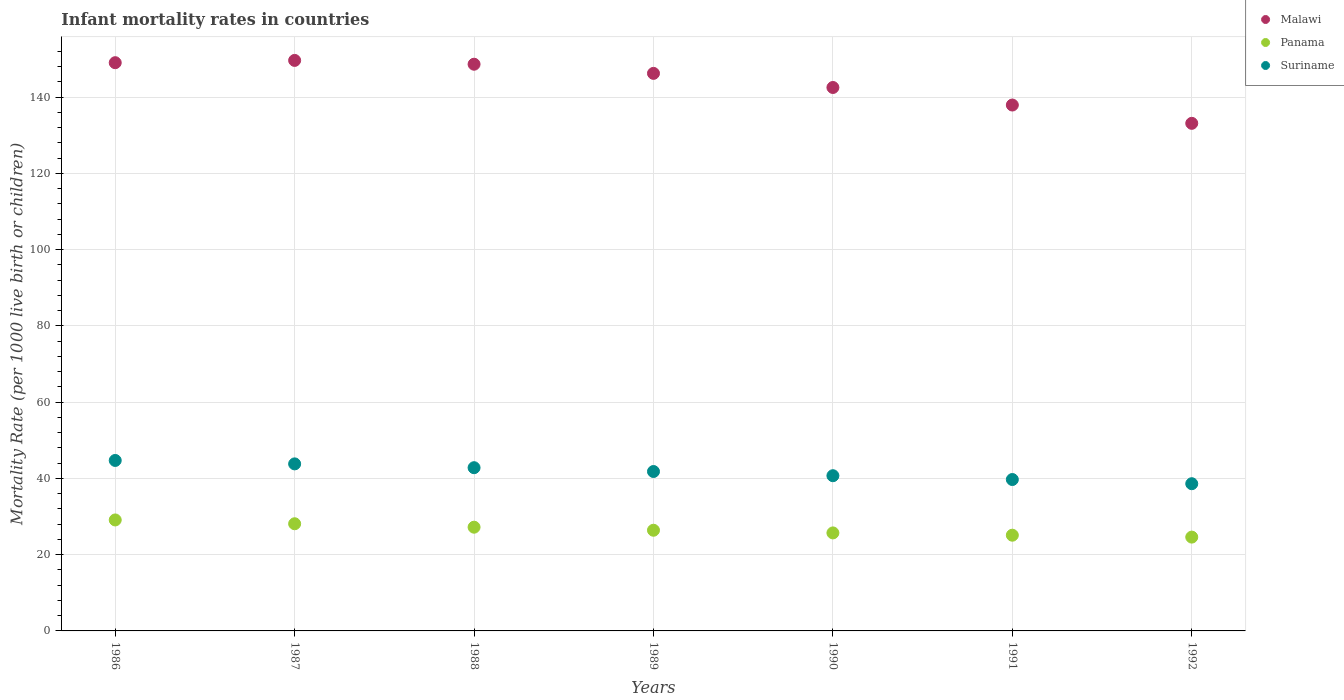Is the number of dotlines equal to the number of legend labels?
Provide a succinct answer. Yes. What is the infant mortality rate in Suriname in 1990?
Ensure brevity in your answer.  40.7. Across all years, what is the maximum infant mortality rate in Suriname?
Your answer should be compact. 44.7. Across all years, what is the minimum infant mortality rate in Suriname?
Give a very brief answer. 38.6. In which year was the infant mortality rate in Malawi minimum?
Offer a very short reply. 1992. What is the total infant mortality rate in Malawi in the graph?
Provide a succinct answer. 1006.9. What is the difference between the infant mortality rate in Suriname in 1989 and that in 1991?
Make the answer very short. 2.1. What is the difference between the infant mortality rate in Panama in 1988 and the infant mortality rate in Malawi in 1990?
Your answer should be very brief. -115.3. What is the average infant mortality rate in Suriname per year?
Your answer should be very brief. 41.73. In the year 1987, what is the difference between the infant mortality rate in Panama and infant mortality rate in Suriname?
Ensure brevity in your answer.  -15.7. What is the ratio of the infant mortality rate in Panama in 1988 to that in 1991?
Provide a short and direct response. 1.08. Is the infant mortality rate in Suriname in 1988 less than that in 1989?
Provide a succinct answer. No. Is the difference between the infant mortality rate in Panama in 1988 and 1989 greater than the difference between the infant mortality rate in Suriname in 1988 and 1989?
Your answer should be compact. No. What is the difference between the highest and the second highest infant mortality rate in Malawi?
Give a very brief answer. 0.6. What is the difference between the highest and the lowest infant mortality rate in Malawi?
Your answer should be very brief. 16.5. In how many years, is the infant mortality rate in Malawi greater than the average infant mortality rate in Malawi taken over all years?
Give a very brief answer. 4. Is the sum of the infant mortality rate in Suriname in 1986 and 1988 greater than the maximum infant mortality rate in Panama across all years?
Offer a very short reply. Yes. Is it the case that in every year, the sum of the infant mortality rate in Suriname and infant mortality rate in Malawi  is greater than the infant mortality rate in Panama?
Offer a very short reply. Yes. Is the infant mortality rate in Suriname strictly greater than the infant mortality rate in Panama over the years?
Make the answer very short. Yes. Is the infant mortality rate in Panama strictly less than the infant mortality rate in Malawi over the years?
Keep it short and to the point. Yes. Are the values on the major ticks of Y-axis written in scientific E-notation?
Keep it short and to the point. No. Does the graph contain any zero values?
Offer a very short reply. No. Does the graph contain grids?
Keep it short and to the point. Yes. Where does the legend appear in the graph?
Your answer should be very brief. Top right. How many legend labels are there?
Make the answer very short. 3. How are the legend labels stacked?
Keep it short and to the point. Vertical. What is the title of the graph?
Provide a succinct answer. Infant mortality rates in countries. What is the label or title of the Y-axis?
Your response must be concise. Mortality Rate (per 1000 live birth or children). What is the Mortality Rate (per 1000 live birth or children) in Malawi in 1986?
Keep it short and to the point. 149. What is the Mortality Rate (per 1000 live birth or children) of Panama in 1986?
Give a very brief answer. 29.1. What is the Mortality Rate (per 1000 live birth or children) in Suriname in 1986?
Offer a very short reply. 44.7. What is the Mortality Rate (per 1000 live birth or children) of Malawi in 1987?
Make the answer very short. 149.6. What is the Mortality Rate (per 1000 live birth or children) in Panama in 1987?
Give a very brief answer. 28.1. What is the Mortality Rate (per 1000 live birth or children) in Suriname in 1987?
Offer a very short reply. 43.8. What is the Mortality Rate (per 1000 live birth or children) in Malawi in 1988?
Provide a short and direct response. 148.6. What is the Mortality Rate (per 1000 live birth or children) of Panama in 1988?
Your answer should be compact. 27.2. What is the Mortality Rate (per 1000 live birth or children) in Suriname in 1988?
Your response must be concise. 42.8. What is the Mortality Rate (per 1000 live birth or children) in Malawi in 1989?
Your response must be concise. 146.2. What is the Mortality Rate (per 1000 live birth or children) in Panama in 1989?
Make the answer very short. 26.4. What is the Mortality Rate (per 1000 live birth or children) of Suriname in 1989?
Offer a terse response. 41.8. What is the Mortality Rate (per 1000 live birth or children) of Malawi in 1990?
Offer a terse response. 142.5. What is the Mortality Rate (per 1000 live birth or children) of Panama in 1990?
Ensure brevity in your answer.  25.7. What is the Mortality Rate (per 1000 live birth or children) in Suriname in 1990?
Your answer should be very brief. 40.7. What is the Mortality Rate (per 1000 live birth or children) of Malawi in 1991?
Provide a short and direct response. 137.9. What is the Mortality Rate (per 1000 live birth or children) of Panama in 1991?
Ensure brevity in your answer.  25.1. What is the Mortality Rate (per 1000 live birth or children) in Suriname in 1991?
Your answer should be very brief. 39.7. What is the Mortality Rate (per 1000 live birth or children) in Malawi in 1992?
Your answer should be compact. 133.1. What is the Mortality Rate (per 1000 live birth or children) in Panama in 1992?
Offer a terse response. 24.6. What is the Mortality Rate (per 1000 live birth or children) of Suriname in 1992?
Make the answer very short. 38.6. Across all years, what is the maximum Mortality Rate (per 1000 live birth or children) in Malawi?
Make the answer very short. 149.6. Across all years, what is the maximum Mortality Rate (per 1000 live birth or children) of Panama?
Your answer should be very brief. 29.1. Across all years, what is the maximum Mortality Rate (per 1000 live birth or children) of Suriname?
Offer a terse response. 44.7. Across all years, what is the minimum Mortality Rate (per 1000 live birth or children) of Malawi?
Ensure brevity in your answer.  133.1. Across all years, what is the minimum Mortality Rate (per 1000 live birth or children) of Panama?
Provide a succinct answer. 24.6. Across all years, what is the minimum Mortality Rate (per 1000 live birth or children) in Suriname?
Your answer should be compact. 38.6. What is the total Mortality Rate (per 1000 live birth or children) of Malawi in the graph?
Your answer should be very brief. 1006.9. What is the total Mortality Rate (per 1000 live birth or children) in Panama in the graph?
Offer a terse response. 186.2. What is the total Mortality Rate (per 1000 live birth or children) in Suriname in the graph?
Keep it short and to the point. 292.1. What is the difference between the Mortality Rate (per 1000 live birth or children) of Malawi in 1986 and that in 1987?
Ensure brevity in your answer.  -0.6. What is the difference between the Mortality Rate (per 1000 live birth or children) of Panama in 1986 and that in 1987?
Ensure brevity in your answer.  1. What is the difference between the Mortality Rate (per 1000 live birth or children) of Suriname in 1986 and that in 1987?
Give a very brief answer. 0.9. What is the difference between the Mortality Rate (per 1000 live birth or children) in Malawi in 1986 and that in 1988?
Offer a very short reply. 0.4. What is the difference between the Mortality Rate (per 1000 live birth or children) of Panama in 1986 and that in 1988?
Offer a very short reply. 1.9. What is the difference between the Mortality Rate (per 1000 live birth or children) of Panama in 1986 and that in 1989?
Your answer should be compact. 2.7. What is the difference between the Mortality Rate (per 1000 live birth or children) in Suriname in 1986 and that in 1989?
Provide a short and direct response. 2.9. What is the difference between the Mortality Rate (per 1000 live birth or children) of Panama in 1986 and that in 1990?
Provide a succinct answer. 3.4. What is the difference between the Mortality Rate (per 1000 live birth or children) of Suriname in 1986 and that in 1990?
Give a very brief answer. 4. What is the difference between the Mortality Rate (per 1000 live birth or children) of Panama in 1986 and that in 1991?
Your answer should be compact. 4. What is the difference between the Mortality Rate (per 1000 live birth or children) of Panama in 1986 and that in 1992?
Ensure brevity in your answer.  4.5. What is the difference between the Mortality Rate (per 1000 live birth or children) of Panama in 1987 and that in 1988?
Give a very brief answer. 0.9. What is the difference between the Mortality Rate (per 1000 live birth or children) in Malawi in 1987 and that in 1989?
Your response must be concise. 3.4. What is the difference between the Mortality Rate (per 1000 live birth or children) of Suriname in 1987 and that in 1989?
Make the answer very short. 2. What is the difference between the Mortality Rate (per 1000 live birth or children) of Panama in 1987 and that in 1990?
Provide a short and direct response. 2.4. What is the difference between the Mortality Rate (per 1000 live birth or children) in Panama in 1987 and that in 1991?
Provide a short and direct response. 3. What is the difference between the Mortality Rate (per 1000 live birth or children) of Malawi in 1988 and that in 1989?
Provide a short and direct response. 2.4. What is the difference between the Mortality Rate (per 1000 live birth or children) of Suriname in 1988 and that in 1989?
Provide a succinct answer. 1. What is the difference between the Mortality Rate (per 1000 live birth or children) of Malawi in 1988 and that in 1991?
Your answer should be very brief. 10.7. What is the difference between the Mortality Rate (per 1000 live birth or children) of Panama in 1988 and that in 1991?
Provide a succinct answer. 2.1. What is the difference between the Mortality Rate (per 1000 live birth or children) in Suriname in 1988 and that in 1991?
Keep it short and to the point. 3.1. What is the difference between the Mortality Rate (per 1000 live birth or children) in Panama in 1988 and that in 1992?
Make the answer very short. 2.6. What is the difference between the Mortality Rate (per 1000 live birth or children) of Malawi in 1989 and that in 1990?
Your response must be concise. 3.7. What is the difference between the Mortality Rate (per 1000 live birth or children) in Suriname in 1989 and that in 1990?
Offer a terse response. 1.1. What is the difference between the Mortality Rate (per 1000 live birth or children) of Panama in 1989 and that in 1991?
Provide a succinct answer. 1.3. What is the difference between the Mortality Rate (per 1000 live birth or children) in Suriname in 1989 and that in 1991?
Provide a short and direct response. 2.1. What is the difference between the Mortality Rate (per 1000 live birth or children) of Malawi in 1989 and that in 1992?
Your response must be concise. 13.1. What is the difference between the Mortality Rate (per 1000 live birth or children) in Panama in 1989 and that in 1992?
Your response must be concise. 1.8. What is the difference between the Mortality Rate (per 1000 live birth or children) in Suriname in 1989 and that in 1992?
Give a very brief answer. 3.2. What is the difference between the Mortality Rate (per 1000 live birth or children) in Panama in 1990 and that in 1991?
Your answer should be compact. 0.6. What is the difference between the Mortality Rate (per 1000 live birth or children) in Suriname in 1990 and that in 1991?
Your answer should be compact. 1. What is the difference between the Mortality Rate (per 1000 live birth or children) of Panama in 1990 and that in 1992?
Your answer should be compact. 1.1. What is the difference between the Mortality Rate (per 1000 live birth or children) in Suriname in 1990 and that in 1992?
Offer a very short reply. 2.1. What is the difference between the Mortality Rate (per 1000 live birth or children) in Malawi in 1991 and that in 1992?
Provide a succinct answer. 4.8. What is the difference between the Mortality Rate (per 1000 live birth or children) of Panama in 1991 and that in 1992?
Your answer should be very brief. 0.5. What is the difference between the Mortality Rate (per 1000 live birth or children) of Suriname in 1991 and that in 1992?
Provide a short and direct response. 1.1. What is the difference between the Mortality Rate (per 1000 live birth or children) of Malawi in 1986 and the Mortality Rate (per 1000 live birth or children) of Panama in 1987?
Give a very brief answer. 120.9. What is the difference between the Mortality Rate (per 1000 live birth or children) in Malawi in 1986 and the Mortality Rate (per 1000 live birth or children) in Suriname in 1987?
Offer a very short reply. 105.2. What is the difference between the Mortality Rate (per 1000 live birth or children) in Panama in 1986 and the Mortality Rate (per 1000 live birth or children) in Suriname in 1987?
Provide a short and direct response. -14.7. What is the difference between the Mortality Rate (per 1000 live birth or children) of Malawi in 1986 and the Mortality Rate (per 1000 live birth or children) of Panama in 1988?
Keep it short and to the point. 121.8. What is the difference between the Mortality Rate (per 1000 live birth or children) in Malawi in 1986 and the Mortality Rate (per 1000 live birth or children) in Suriname in 1988?
Provide a short and direct response. 106.2. What is the difference between the Mortality Rate (per 1000 live birth or children) of Panama in 1986 and the Mortality Rate (per 1000 live birth or children) of Suriname in 1988?
Provide a succinct answer. -13.7. What is the difference between the Mortality Rate (per 1000 live birth or children) of Malawi in 1986 and the Mortality Rate (per 1000 live birth or children) of Panama in 1989?
Your response must be concise. 122.6. What is the difference between the Mortality Rate (per 1000 live birth or children) of Malawi in 1986 and the Mortality Rate (per 1000 live birth or children) of Suriname in 1989?
Your response must be concise. 107.2. What is the difference between the Mortality Rate (per 1000 live birth or children) in Panama in 1986 and the Mortality Rate (per 1000 live birth or children) in Suriname in 1989?
Ensure brevity in your answer.  -12.7. What is the difference between the Mortality Rate (per 1000 live birth or children) in Malawi in 1986 and the Mortality Rate (per 1000 live birth or children) in Panama in 1990?
Provide a short and direct response. 123.3. What is the difference between the Mortality Rate (per 1000 live birth or children) in Malawi in 1986 and the Mortality Rate (per 1000 live birth or children) in Suriname in 1990?
Provide a short and direct response. 108.3. What is the difference between the Mortality Rate (per 1000 live birth or children) of Malawi in 1986 and the Mortality Rate (per 1000 live birth or children) of Panama in 1991?
Your response must be concise. 123.9. What is the difference between the Mortality Rate (per 1000 live birth or children) in Malawi in 1986 and the Mortality Rate (per 1000 live birth or children) in Suriname in 1991?
Your answer should be compact. 109.3. What is the difference between the Mortality Rate (per 1000 live birth or children) in Malawi in 1986 and the Mortality Rate (per 1000 live birth or children) in Panama in 1992?
Offer a very short reply. 124.4. What is the difference between the Mortality Rate (per 1000 live birth or children) in Malawi in 1986 and the Mortality Rate (per 1000 live birth or children) in Suriname in 1992?
Keep it short and to the point. 110.4. What is the difference between the Mortality Rate (per 1000 live birth or children) of Panama in 1986 and the Mortality Rate (per 1000 live birth or children) of Suriname in 1992?
Provide a succinct answer. -9.5. What is the difference between the Mortality Rate (per 1000 live birth or children) of Malawi in 1987 and the Mortality Rate (per 1000 live birth or children) of Panama in 1988?
Provide a succinct answer. 122.4. What is the difference between the Mortality Rate (per 1000 live birth or children) in Malawi in 1987 and the Mortality Rate (per 1000 live birth or children) in Suriname in 1988?
Your answer should be very brief. 106.8. What is the difference between the Mortality Rate (per 1000 live birth or children) in Panama in 1987 and the Mortality Rate (per 1000 live birth or children) in Suriname in 1988?
Provide a succinct answer. -14.7. What is the difference between the Mortality Rate (per 1000 live birth or children) of Malawi in 1987 and the Mortality Rate (per 1000 live birth or children) of Panama in 1989?
Offer a very short reply. 123.2. What is the difference between the Mortality Rate (per 1000 live birth or children) in Malawi in 1987 and the Mortality Rate (per 1000 live birth or children) in Suriname in 1989?
Provide a short and direct response. 107.8. What is the difference between the Mortality Rate (per 1000 live birth or children) of Panama in 1987 and the Mortality Rate (per 1000 live birth or children) of Suriname in 1989?
Keep it short and to the point. -13.7. What is the difference between the Mortality Rate (per 1000 live birth or children) in Malawi in 1987 and the Mortality Rate (per 1000 live birth or children) in Panama in 1990?
Ensure brevity in your answer.  123.9. What is the difference between the Mortality Rate (per 1000 live birth or children) of Malawi in 1987 and the Mortality Rate (per 1000 live birth or children) of Suriname in 1990?
Your answer should be compact. 108.9. What is the difference between the Mortality Rate (per 1000 live birth or children) in Panama in 1987 and the Mortality Rate (per 1000 live birth or children) in Suriname in 1990?
Ensure brevity in your answer.  -12.6. What is the difference between the Mortality Rate (per 1000 live birth or children) in Malawi in 1987 and the Mortality Rate (per 1000 live birth or children) in Panama in 1991?
Make the answer very short. 124.5. What is the difference between the Mortality Rate (per 1000 live birth or children) of Malawi in 1987 and the Mortality Rate (per 1000 live birth or children) of Suriname in 1991?
Provide a short and direct response. 109.9. What is the difference between the Mortality Rate (per 1000 live birth or children) of Malawi in 1987 and the Mortality Rate (per 1000 live birth or children) of Panama in 1992?
Provide a short and direct response. 125. What is the difference between the Mortality Rate (per 1000 live birth or children) of Malawi in 1987 and the Mortality Rate (per 1000 live birth or children) of Suriname in 1992?
Give a very brief answer. 111. What is the difference between the Mortality Rate (per 1000 live birth or children) in Panama in 1987 and the Mortality Rate (per 1000 live birth or children) in Suriname in 1992?
Give a very brief answer. -10.5. What is the difference between the Mortality Rate (per 1000 live birth or children) in Malawi in 1988 and the Mortality Rate (per 1000 live birth or children) in Panama in 1989?
Provide a short and direct response. 122.2. What is the difference between the Mortality Rate (per 1000 live birth or children) in Malawi in 1988 and the Mortality Rate (per 1000 live birth or children) in Suriname in 1989?
Make the answer very short. 106.8. What is the difference between the Mortality Rate (per 1000 live birth or children) of Panama in 1988 and the Mortality Rate (per 1000 live birth or children) of Suriname in 1989?
Your answer should be very brief. -14.6. What is the difference between the Mortality Rate (per 1000 live birth or children) in Malawi in 1988 and the Mortality Rate (per 1000 live birth or children) in Panama in 1990?
Give a very brief answer. 122.9. What is the difference between the Mortality Rate (per 1000 live birth or children) in Malawi in 1988 and the Mortality Rate (per 1000 live birth or children) in Suriname in 1990?
Provide a succinct answer. 107.9. What is the difference between the Mortality Rate (per 1000 live birth or children) in Malawi in 1988 and the Mortality Rate (per 1000 live birth or children) in Panama in 1991?
Make the answer very short. 123.5. What is the difference between the Mortality Rate (per 1000 live birth or children) of Malawi in 1988 and the Mortality Rate (per 1000 live birth or children) of Suriname in 1991?
Your response must be concise. 108.9. What is the difference between the Mortality Rate (per 1000 live birth or children) in Malawi in 1988 and the Mortality Rate (per 1000 live birth or children) in Panama in 1992?
Your response must be concise. 124. What is the difference between the Mortality Rate (per 1000 live birth or children) of Malawi in 1988 and the Mortality Rate (per 1000 live birth or children) of Suriname in 1992?
Give a very brief answer. 110. What is the difference between the Mortality Rate (per 1000 live birth or children) in Malawi in 1989 and the Mortality Rate (per 1000 live birth or children) in Panama in 1990?
Make the answer very short. 120.5. What is the difference between the Mortality Rate (per 1000 live birth or children) in Malawi in 1989 and the Mortality Rate (per 1000 live birth or children) in Suriname in 1990?
Ensure brevity in your answer.  105.5. What is the difference between the Mortality Rate (per 1000 live birth or children) of Panama in 1989 and the Mortality Rate (per 1000 live birth or children) of Suriname in 1990?
Ensure brevity in your answer.  -14.3. What is the difference between the Mortality Rate (per 1000 live birth or children) in Malawi in 1989 and the Mortality Rate (per 1000 live birth or children) in Panama in 1991?
Make the answer very short. 121.1. What is the difference between the Mortality Rate (per 1000 live birth or children) of Malawi in 1989 and the Mortality Rate (per 1000 live birth or children) of Suriname in 1991?
Provide a short and direct response. 106.5. What is the difference between the Mortality Rate (per 1000 live birth or children) in Panama in 1989 and the Mortality Rate (per 1000 live birth or children) in Suriname in 1991?
Give a very brief answer. -13.3. What is the difference between the Mortality Rate (per 1000 live birth or children) in Malawi in 1989 and the Mortality Rate (per 1000 live birth or children) in Panama in 1992?
Your answer should be very brief. 121.6. What is the difference between the Mortality Rate (per 1000 live birth or children) of Malawi in 1989 and the Mortality Rate (per 1000 live birth or children) of Suriname in 1992?
Make the answer very short. 107.6. What is the difference between the Mortality Rate (per 1000 live birth or children) in Panama in 1989 and the Mortality Rate (per 1000 live birth or children) in Suriname in 1992?
Give a very brief answer. -12.2. What is the difference between the Mortality Rate (per 1000 live birth or children) in Malawi in 1990 and the Mortality Rate (per 1000 live birth or children) in Panama in 1991?
Provide a succinct answer. 117.4. What is the difference between the Mortality Rate (per 1000 live birth or children) of Malawi in 1990 and the Mortality Rate (per 1000 live birth or children) of Suriname in 1991?
Ensure brevity in your answer.  102.8. What is the difference between the Mortality Rate (per 1000 live birth or children) of Panama in 1990 and the Mortality Rate (per 1000 live birth or children) of Suriname in 1991?
Offer a very short reply. -14. What is the difference between the Mortality Rate (per 1000 live birth or children) in Malawi in 1990 and the Mortality Rate (per 1000 live birth or children) in Panama in 1992?
Offer a very short reply. 117.9. What is the difference between the Mortality Rate (per 1000 live birth or children) of Malawi in 1990 and the Mortality Rate (per 1000 live birth or children) of Suriname in 1992?
Give a very brief answer. 103.9. What is the difference between the Mortality Rate (per 1000 live birth or children) of Panama in 1990 and the Mortality Rate (per 1000 live birth or children) of Suriname in 1992?
Your answer should be compact. -12.9. What is the difference between the Mortality Rate (per 1000 live birth or children) in Malawi in 1991 and the Mortality Rate (per 1000 live birth or children) in Panama in 1992?
Keep it short and to the point. 113.3. What is the difference between the Mortality Rate (per 1000 live birth or children) of Malawi in 1991 and the Mortality Rate (per 1000 live birth or children) of Suriname in 1992?
Offer a terse response. 99.3. What is the average Mortality Rate (per 1000 live birth or children) in Malawi per year?
Your answer should be very brief. 143.84. What is the average Mortality Rate (per 1000 live birth or children) of Panama per year?
Keep it short and to the point. 26.6. What is the average Mortality Rate (per 1000 live birth or children) in Suriname per year?
Your response must be concise. 41.73. In the year 1986, what is the difference between the Mortality Rate (per 1000 live birth or children) of Malawi and Mortality Rate (per 1000 live birth or children) of Panama?
Offer a very short reply. 119.9. In the year 1986, what is the difference between the Mortality Rate (per 1000 live birth or children) of Malawi and Mortality Rate (per 1000 live birth or children) of Suriname?
Your response must be concise. 104.3. In the year 1986, what is the difference between the Mortality Rate (per 1000 live birth or children) in Panama and Mortality Rate (per 1000 live birth or children) in Suriname?
Keep it short and to the point. -15.6. In the year 1987, what is the difference between the Mortality Rate (per 1000 live birth or children) of Malawi and Mortality Rate (per 1000 live birth or children) of Panama?
Ensure brevity in your answer.  121.5. In the year 1987, what is the difference between the Mortality Rate (per 1000 live birth or children) in Malawi and Mortality Rate (per 1000 live birth or children) in Suriname?
Give a very brief answer. 105.8. In the year 1987, what is the difference between the Mortality Rate (per 1000 live birth or children) of Panama and Mortality Rate (per 1000 live birth or children) of Suriname?
Ensure brevity in your answer.  -15.7. In the year 1988, what is the difference between the Mortality Rate (per 1000 live birth or children) of Malawi and Mortality Rate (per 1000 live birth or children) of Panama?
Provide a short and direct response. 121.4. In the year 1988, what is the difference between the Mortality Rate (per 1000 live birth or children) in Malawi and Mortality Rate (per 1000 live birth or children) in Suriname?
Keep it short and to the point. 105.8. In the year 1988, what is the difference between the Mortality Rate (per 1000 live birth or children) of Panama and Mortality Rate (per 1000 live birth or children) of Suriname?
Provide a succinct answer. -15.6. In the year 1989, what is the difference between the Mortality Rate (per 1000 live birth or children) of Malawi and Mortality Rate (per 1000 live birth or children) of Panama?
Provide a short and direct response. 119.8. In the year 1989, what is the difference between the Mortality Rate (per 1000 live birth or children) of Malawi and Mortality Rate (per 1000 live birth or children) of Suriname?
Provide a succinct answer. 104.4. In the year 1989, what is the difference between the Mortality Rate (per 1000 live birth or children) of Panama and Mortality Rate (per 1000 live birth or children) of Suriname?
Ensure brevity in your answer.  -15.4. In the year 1990, what is the difference between the Mortality Rate (per 1000 live birth or children) in Malawi and Mortality Rate (per 1000 live birth or children) in Panama?
Your answer should be very brief. 116.8. In the year 1990, what is the difference between the Mortality Rate (per 1000 live birth or children) of Malawi and Mortality Rate (per 1000 live birth or children) of Suriname?
Provide a short and direct response. 101.8. In the year 1991, what is the difference between the Mortality Rate (per 1000 live birth or children) in Malawi and Mortality Rate (per 1000 live birth or children) in Panama?
Your response must be concise. 112.8. In the year 1991, what is the difference between the Mortality Rate (per 1000 live birth or children) of Malawi and Mortality Rate (per 1000 live birth or children) of Suriname?
Your response must be concise. 98.2. In the year 1991, what is the difference between the Mortality Rate (per 1000 live birth or children) in Panama and Mortality Rate (per 1000 live birth or children) in Suriname?
Give a very brief answer. -14.6. In the year 1992, what is the difference between the Mortality Rate (per 1000 live birth or children) of Malawi and Mortality Rate (per 1000 live birth or children) of Panama?
Offer a terse response. 108.5. In the year 1992, what is the difference between the Mortality Rate (per 1000 live birth or children) of Malawi and Mortality Rate (per 1000 live birth or children) of Suriname?
Your response must be concise. 94.5. In the year 1992, what is the difference between the Mortality Rate (per 1000 live birth or children) of Panama and Mortality Rate (per 1000 live birth or children) of Suriname?
Provide a short and direct response. -14. What is the ratio of the Mortality Rate (per 1000 live birth or children) in Malawi in 1986 to that in 1987?
Give a very brief answer. 1. What is the ratio of the Mortality Rate (per 1000 live birth or children) of Panama in 1986 to that in 1987?
Offer a terse response. 1.04. What is the ratio of the Mortality Rate (per 1000 live birth or children) of Suriname in 1986 to that in 1987?
Provide a short and direct response. 1.02. What is the ratio of the Mortality Rate (per 1000 live birth or children) of Malawi in 1986 to that in 1988?
Make the answer very short. 1. What is the ratio of the Mortality Rate (per 1000 live birth or children) of Panama in 1986 to that in 1988?
Your answer should be very brief. 1.07. What is the ratio of the Mortality Rate (per 1000 live birth or children) in Suriname in 1986 to that in 1988?
Ensure brevity in your answer.  1.04. What is the ratio of the Mortality Rate (per 1000 live birth or children) in Malawi in 1986 to that in 1989?
Provide a short and direct response. 1.02. What is the ratio of the Mortality Rate (per 1000 live birth or children) in Panama in 1986 to that in 1989?
Keep it short and to the point. 1.1. What is the ratio of the Mortality Rate (per 1000 live birth or children) of Suriname in 1986 to that in 1989?
Provide a short and direct response. 1.07. What is the ratio of the Mortality Rate (per 1000 live birth or children) of Malawi in 1986 to that in 1990?
Your response must be concise. 1.05. What is the ratio of the Mortality Rate (per 1000 live birth or children) in Panama in 1986 to that in 1990?
Your answer should be very brief. 1.13. What is the ratio of the Mortality Rate (per 1000 live birth or children) in Suriname in 1986 to that in 1990?
Provide a short and direct response. 1.1. What is the ratio of the Mortality Rate (per 1000 live birth or children) of Malawi in 1986 to that in 1991?
Your response must be concise. 1.08. What is the ratio of the Mortality Rate (per 1000 live birth or children) of Panama in 1986 to that in 1991?
Ensure brevity in your answer.  1.16. What is the ratio of the Mortality Rate (per 1000 live birth or children) of Suriname in 1986 to that in 1991?
Your response must be concise. 1.13. What is the ratio of the Mortality Rate (per 1000 live birth or children) in Malawi in 1986 to that in 1992?
Keep it short and to the point. 1.12. What is the ratio of the Mortality Rate (per 1000 live birth or children) of Panama in 1986 to that in 1992?
Your answer should be compact. 1.18. What is the ratio of the Mortality Rate (per 1000 live birth or children) in Suriname in 1986 to that in 1992?
Your answer should be very brief. 1.16. What is the ratio of the Mortality Rate (per 1000 live birth or children) in Malawi in 1987 to that in 1988?
Keep it short and to the point. 1.01. What is the ratio of the Mortality Rate (per 1000 live birth or children) of Panama in 1987 to that in 1988?
Offer a terse response. 1.03. What is the ratio of the Mortality Rate (per 1000 live birth or children) of Suriname in 1987 to that in 1988?
Provide a succinct answer. 1.02. What is the ratio of the Mortality Rate (per 1000 live birth or children) in Malawi in 1987 to that in 1989?
Provide a short and direct response. 1.02. What is the ratio of the Mortality Rate (per 1000 live birth or children) of Panama in 1987 to that in 1989?
Provide a short and direct response. 1.06. What is the ratio of the Mortality Rate (per 1000 live birth or children) of Suriname in 1987 to that in 1989?
Your answer should be compact. 1.05. What is the ratio of the Mortality Rate (per 1000 live birth or children) of Malawi in 1987 to that in 1990?
Offer a very short reply. 1.05. What is the ratio of the Mortality Rate (per 1000 live birth or children) in Panama in 1987 to that in 1990?
Provide a succinct answer. 1.09. What is the ratio of the Mortality Rate (per 1000 live birth or children) in Suriname in 1987 to that in 1990?
Your answer should be compact. 1.08. What is the ratio of the Mortality Rate (per 1000 live birth or children) of Malawi in 1987 to that in 1991?
Offer a very short reply. 1.08. What is the ratio of the Mortality Rate (per 1000 live birth or children) in Panama in 1987 to that in 1991?
Your answer should be very brief. 1.12. What is the ratio of the Mortality Rate (per 1000 live birth or children) of Suriname in 1987 to that in 1991?
Provide a succinct answer. 1.1. What is the ratio of the Mortality Rate (per 1000 live birth or children) of Malawi in 1987 to that in 1992?
Make the answer very short. 1.12. What is the ratio of the Mortality Rate (per 1000 live birth or children) in Panama in 1987 to that in 1992?
Make the answer very short. 1.14. What is the ratio of the Mortality Rate (per 1000 live birth or children) in Suriname in 1987 to that in 1992?
Give a very brief answer. 1.13. What is the ratio of the Mortality Rate (per 1000 live birth or children) in Malawi in 1988 to that in 1989?
Give a very brief answer. 1.02. What is the ratio of the Mortality Rate (per 1000 live birth or children) of Panama in 1988 to that in 1989?
Your response must be concise. 1.03. What is the ratio of the Mortality Rate (per 1000 live birth or children) of Suriname in 1988 to that in 1989?
Provide a succinct answer. 1.02. What is the ratio of the Mortality Rate (per 1000 live birth or children) of Malawi in 1988 to that in 1990?
Make the answer very short. 1.04. What is the ratio of the Mortality Rate (per 1000 live birth or children) of Panama in 1988 to that in 1990?
Make the answer very short. 1.06. What is the ratio of the Mortality Rate (per 1000 live birth or children) in Suriname in 1988 to that in 1990?
Keep it short and to the point. 1.05. What is the ratio of the Mortality Rate (per 1000 live birth or children) in Malawi in 1988 to that in 1991?
Keep it short and to the point. 1.08. What is the ratio of the Mortality Rate (per 1000 live birth or children) in Panama in 1988 to that in 1991?
Your answer should be compact. 1.08. What is the ratio of the Mortality Rate (per 1000 live birth or children) of Suriname in 1988 to that in 1991?
Make the answer very short. 1.08. What is the ratio of the Mortality Rate (per 1000 live birth or children) of Malawi in 1988 to that in 1992?
Provide a succinct answer. 1.12. What is the ratio of the Mortality Rate (per 1000 live birth or children) of Panama in 1988 to that in 1992?
Ensure brevity in your answer.  1.11. What is the ratio of the Mortality Rate (per 1000 live birth or children) of Suriname in 1988 to that in 1992?
Your response must be concise. 1.11. What is the ratio of the Mortality Rate (per 1000 live birth or children) in Malawi in 1989 to that in 1990?
Your answer should be very brief. 1.03. What is the ratio of the Mortality Rate (per 1000 live birth or children) in Panama in 1989 to that in 1990?
Provide a short and direct response. 1.03. What is the ratio of the Mortality Rate (per 1000 live birth or children) of Suriname in 1989 to that in 1990?
Make the answer very short. 1.03. What is the ratio of the Mortality Rate (per 1000 live birth or children) of Malawi in 1989 to that in 1991?
Make the answer very short. 1.06. What is the ratio of the Mortality Rate (per 1000 live birth or children) of Panama in 1989 to that in 1991?
Your response must be concise. 1.05. What is the ratio of the Mortality Rate (per 1000 live birth or children) in Suriname in 1989 to that in 1991?
Give a very brief answer. 1.05. What is the ratio of the Mortality Rate (per 1000 live birth or children) in Malawi in 1989 to that in 1992?
Keep it short and to the point. 1.1. What is the ratio of the Mortality Rate (per 1000 live birth or children) in Panama in 1989 to that in 1992?
Ensure brevity in your answer.  1.07. What is the ratio of the Mortality Rate (per 1000 live birth or children) in Suriname in 1989 to that in 1992?
Your response must be concise. 1.08. What is the ratio of the Mortality Rate (per 1000 live birth or children) in Malawi in 1990 to that in 1991?
Offer a very short reply. 1.03. What is the ratio of the Mortality Rate (per 1000 live birth or children) of Panama in 1990 to that in 1991?
Give a very brief answer. 1.02. What is the ratio of the Mortality Rate (per 1000 live birth or children) in Suriname in 1990 to that in 1991?
Make the answer very short. 1.03. What is the ratio of the Mortality Rate (per 1000 live birth or children) in Malawi in 1990 to that in 1992?
Offer a terse response. 1.07. What is the ratio of the Mortality Rate (per 1000 live birth or children) in Panama in 1990 to that in 1992?
Ensure brevity in your answer.  1.04. What is the ratio of the Mortality Rate (per 1000 live birth or children) in Suriname in 1990 to that in 1992?
Ensure brevity in your answer.  1.05. What is the ratio of the Mortality Rate (per 1000 live birth or children) in Malawi in 1991 to that in 1992?
Provide a succinct answer. 1.04. What is the ratio of the Mortality Rate (per 1000 live birth or children) in Panama in 1991 to that in 1992?
Give a very brief answer. 1.02. What is the ratio of the Mortality Rate (per 1000 live birth or children) of Suriname in 1991 to that in 1992?
Make the answer very short. 1.03. What is the difference between the highest and the second highest Mortality Rate (per 1000 live birth or children) of Panama?
Offer a very short reply. 1. What is the difference between the highest and the second highest Mortality Rate (per 1000 live birth or children) of Suriname?
Provide a succinct answer. 0.9. What is the difference between the highest and the lowest Mortality Rate (per 1000 live birth or children) in Malawi?
Your answer should be compact. 16.5. 